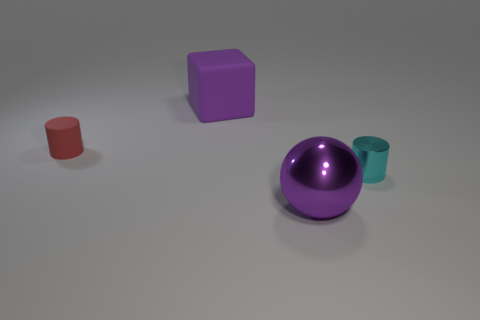Does the big metal thing have the same color as the large matte block?
Make the answer very short. Yes. There is a tiny cylinder on the right side of the metallic sphere; what is its material?
Your answer should be very brief. Metal. There is a object that is right of the big purple object in front of the small thing that is to the right of the big metallic sphere; what is its material?
Your answer should be compact. Metal. What number of cylinders are large purple metal things or large purple matte objects?
Offer a very short reply. 0. Are there the same number of purple cubes behind the tiny cyan cylinder and large purple metallic things that are to the right of the purple metal sphere?
Provide a short and direct response. No. How many tiny shiny objects are to the left of the tiny cyan thing on the right side of the purple metallic ball that is in front of the red rubber thing?
Ensure brevity in your answer.  0. There is another thing that is the same color as the big rubber object; what shape is it?
Offer a terse response. Sphere. Do the small rubber object and the rubber thing behind the red matte cylinder have the same color?
Your answer should be compact. No. Are there more cylinders behind the tiny cyan cylinder than large gray rubber blocks?
Provide a short and direct response. Yes. What number of objects are either rubber objects on the left side of the big purple rubber cube or large things that are to the left of the large purple metallic object?
Make the answer very short. 2. 